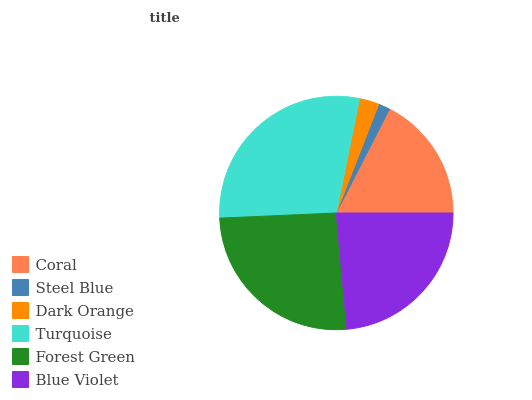Is Steel Blue the minimum?
Answer yes or no. Yes. Is Turquoise the maximum?
Answer yes or no. Yes. Is Dark Orange the minimum?
Answer yes or no. No. Is Dark Orange the maximum?
Answer yes or no. No. Is Dark Orange greater than Steel Blue?
Answer yes or no. Yes. Is Steel Blue less than Dark Orange?
Answer yes or no. Yes. Is Steel Blue greater than Dark Orange?
Answer yes or no. No. Is Dark Orange less than Steel Blue?
Answer yes or no. No. Is Blue Violet the high median?
Answer yes or no. Yes. Is Coral the low median?
Answer yes or no. Yes. Is Turquoise the high median?
Answer yes or no. No. Is Steel Blue the low median?
Answer yes or no. No. 